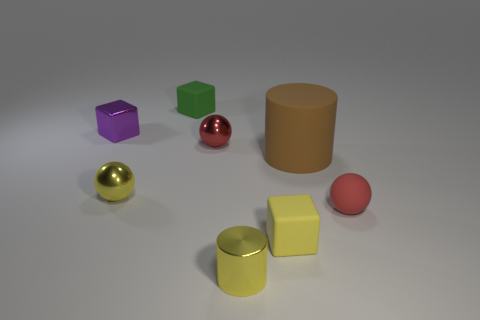Are there any tiny yellow cylinders made of the same material as the tiny purple block?
Make the answer very short. Yes. What number of balls are either red rubber things or yellow metal objects?
Provide a succinct answer. 2. There is a metal thing that is to the right of the red metal object; is there a big thing that is on the left side of it?
Offer a very short reply. No. Is the number of tiny matte balls less than the number of rubber objects?
Offer a terse response. Yes. What number of other yellow rubber objects have the same shape as the small yellow rubber thing?
Provide a succinct answer. 0. What number of gray things are either tiny matte cubes or big cylinders?
Offer a terse response. 0. How big is the cylinder behind the small metallic sphere in front of the brown cylinder?
Offer a terse response. Large. There is a small yellow thing that is the same shape as the green rubber object; what is it made of?
Your answer should be very brief. Rubber. How many red rubber objects have the same size as the shiny cube?
Your response must be concise. 1. Is the yellow matte thing the same size as the brown matte thing?
Offer a very short reply. No. 